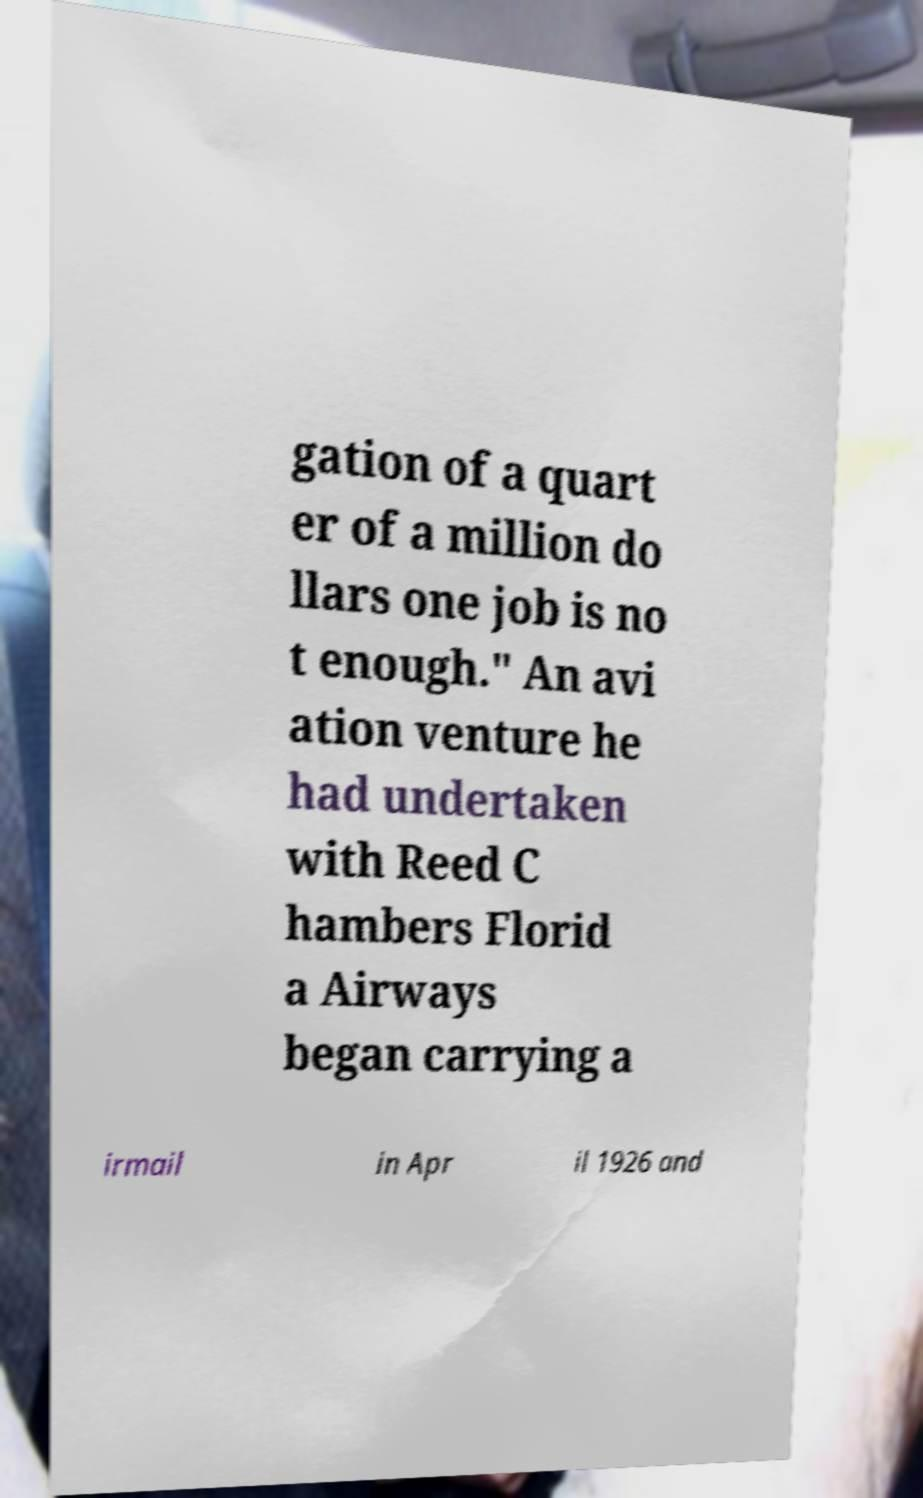Please read and relay the text visible in this image. What does it say? gation of a quart er of a million do llars one job is no t enough." An avi ation venture he had undertaken with Reed C hambers Florid a Airways began carrying a irmail in Apr il 1926 and 